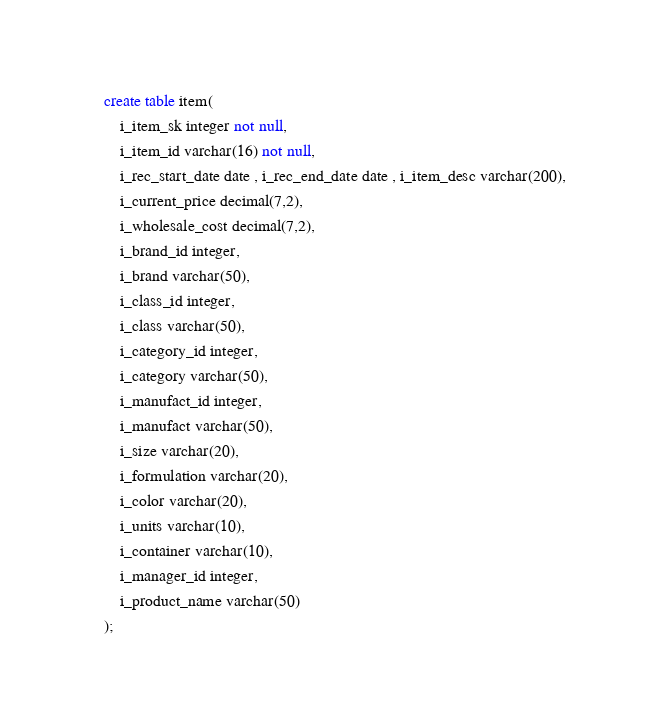<code> <loc_0><loc_0><loc_500><loc_500><_SQL_>create table item(
	i_item_sk integer not null,
	i_item_id varchar(16) not null,
	i_rec_start_date date , i_rec_end_date date , i_item_desc varchar(200),
	i_current_price decimal(7,2),
	i_wholesale_cost decimal(7,2),
	i_brand_id integer,
	i_brand varchar(50),
	i_class_id integer,
	i_class varchar(50),
	i_category_id integer,
	i_category varchar(50),
	i_manufact_id integer,
	i_manufact varchar(50),
	i_size varchar(20),
	i_formulation varchar(20),
	i_color varchar(20),
	i_units varchar(10),
	i_container varchar(10),
	i_manager_id integer,
	i_product_name varchar(50)
);
</code> 